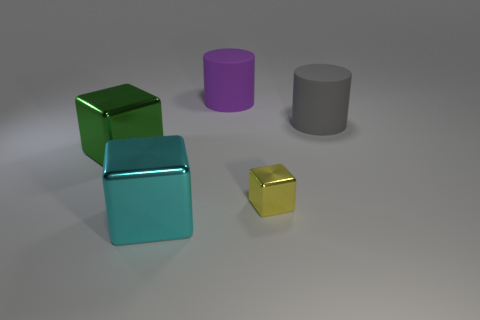What might be the purpose of these objects in a real-world setting? These objects, given their simple geometric shapes and smooth surfaces, could serve as an array of purposes ranging from decorative pieces, such as modern art sculptures, to functional elements in educational settings for teaching geometry and spatial relations. 